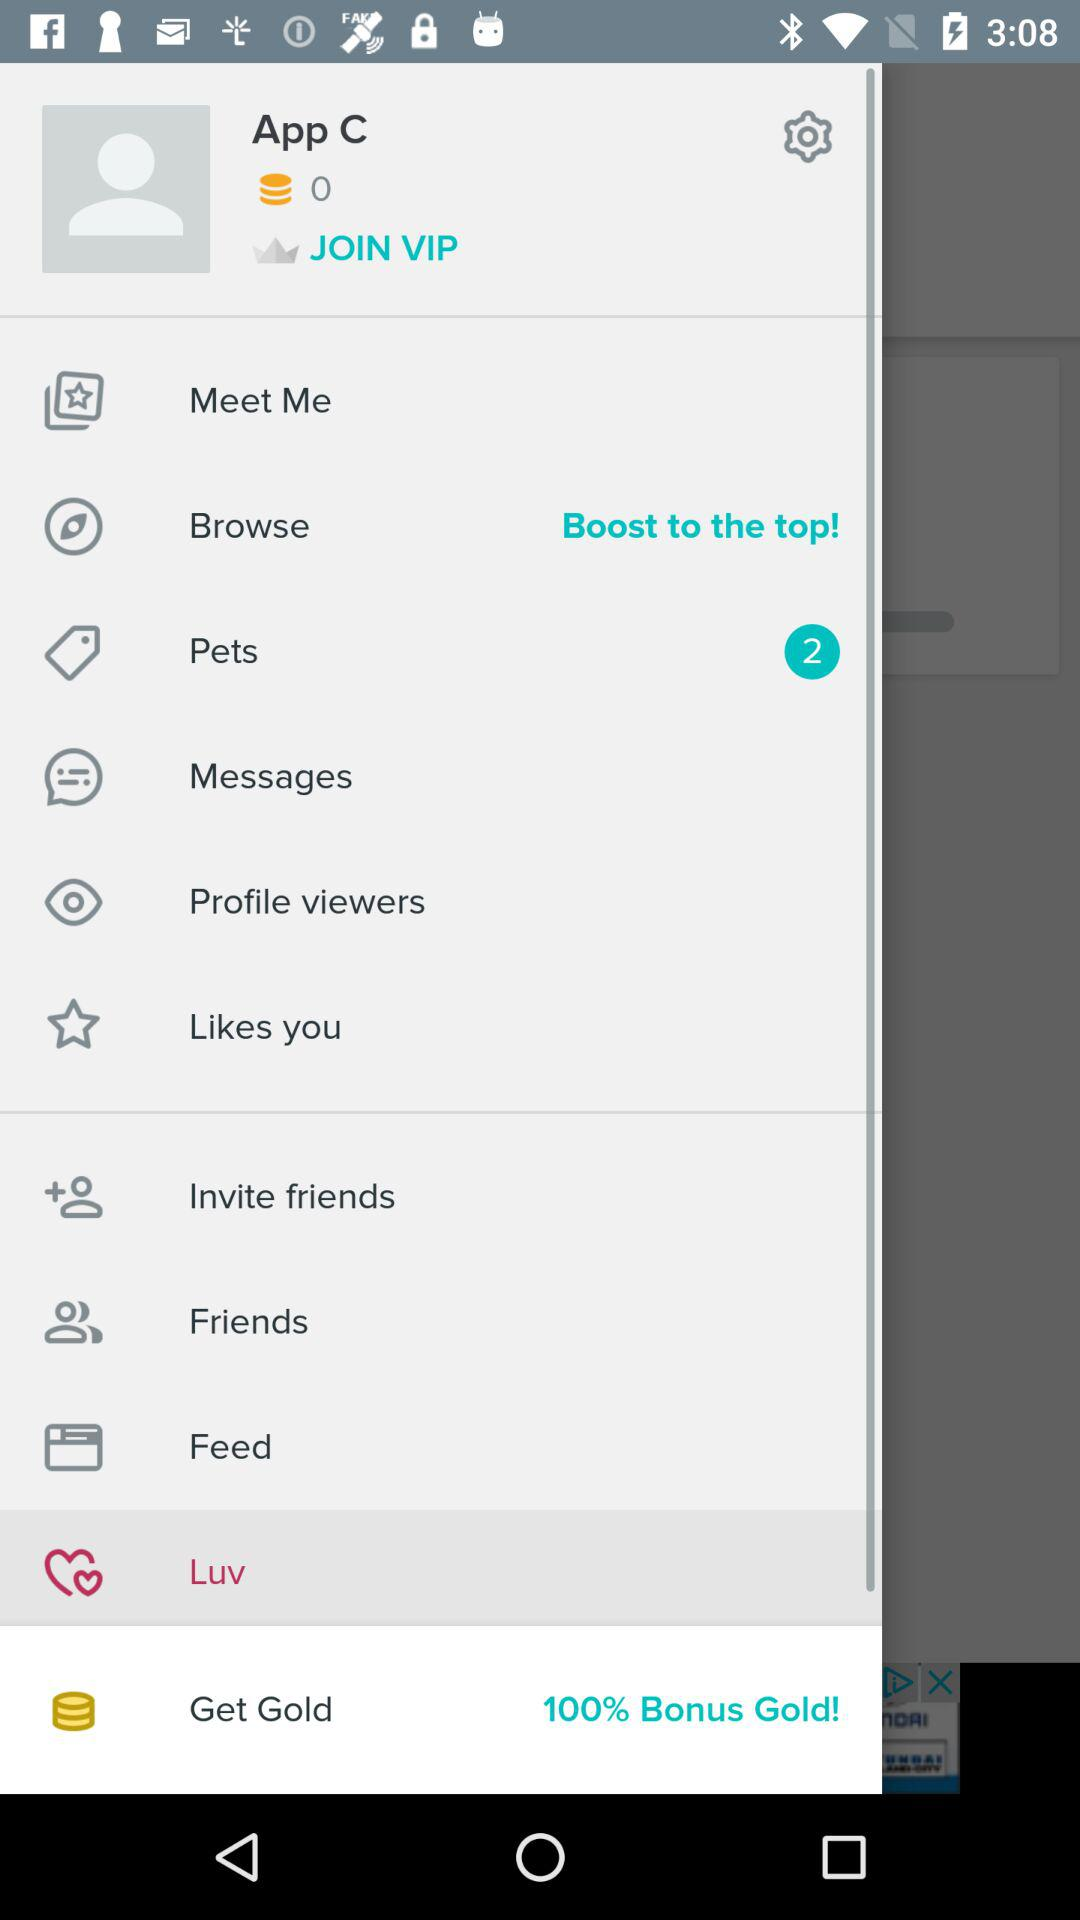How many pending notifications are there for pets? There are 2 pending notifications. 